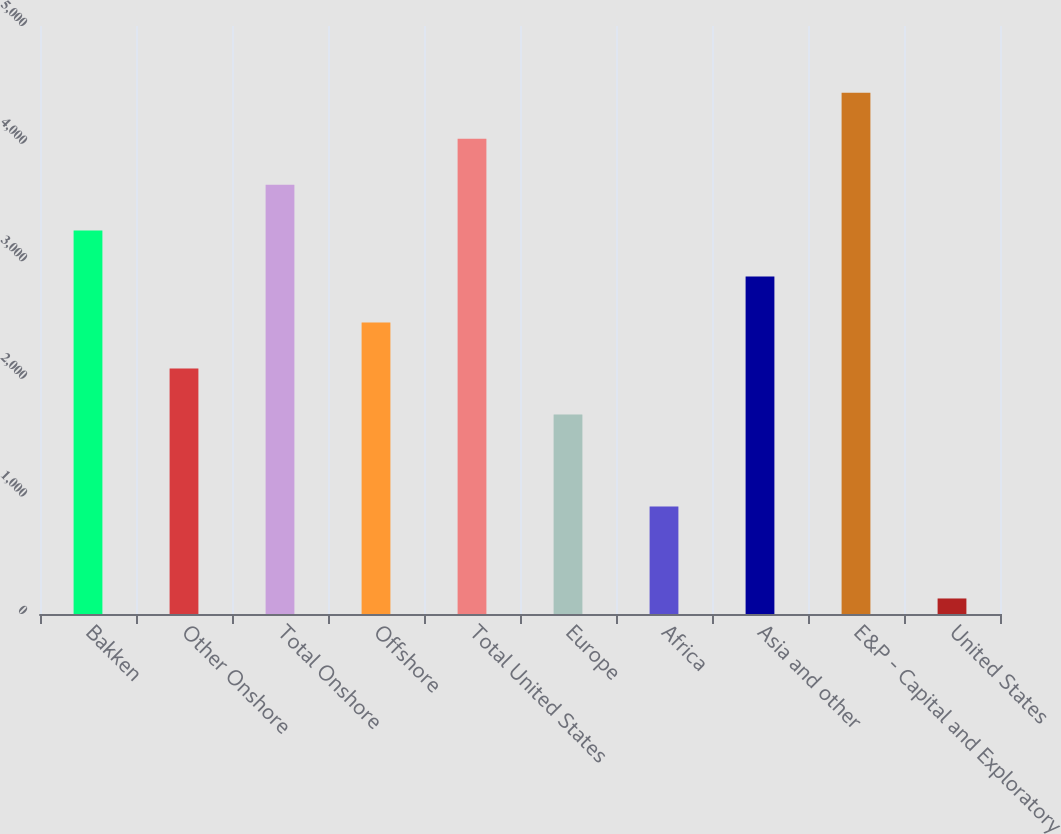Convert chart. <chart><loc_0><loc_0><loc_500><loc_500><bar_chart><fcel>Bakken<fcel>Other Onshore<fcel>Total Onshore<fcel>Offshore<fcel>Total United States<fcel>Europe<fcel>Africa<fcel>Asia and other<fcel>E&P - Capital and Exploratory<fcel>United States<nl><fcel>3260<fcel>2087<fcel>3651<fcel>2478<fcel>4042<fcel>1696<fcel>914<fcel>2869<fcel>4433<fcel>132<nl></chart> 